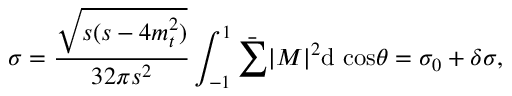Convert formula to latex. <formula><loc_0><loc_0><loc_500><loc_500>\sigma = \frac { \sqrt { s ( s - 4 m _ { t } ^ { 2 } ) } } { 3 2 \pi s ^ { 2 } } \int _ { - 1 } ^ { 1 } \bar { \sum } | M | ^ { 2 } d \ \cos \theta = \sigma _ { 0 } + \delta \sigma ,</formula> 